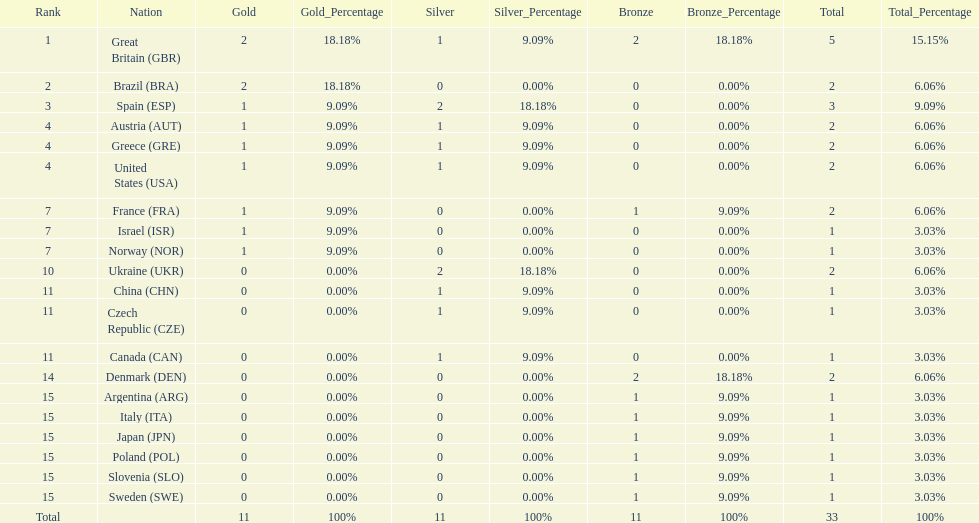Which country won the most medals total? Great Britain (GBR). 